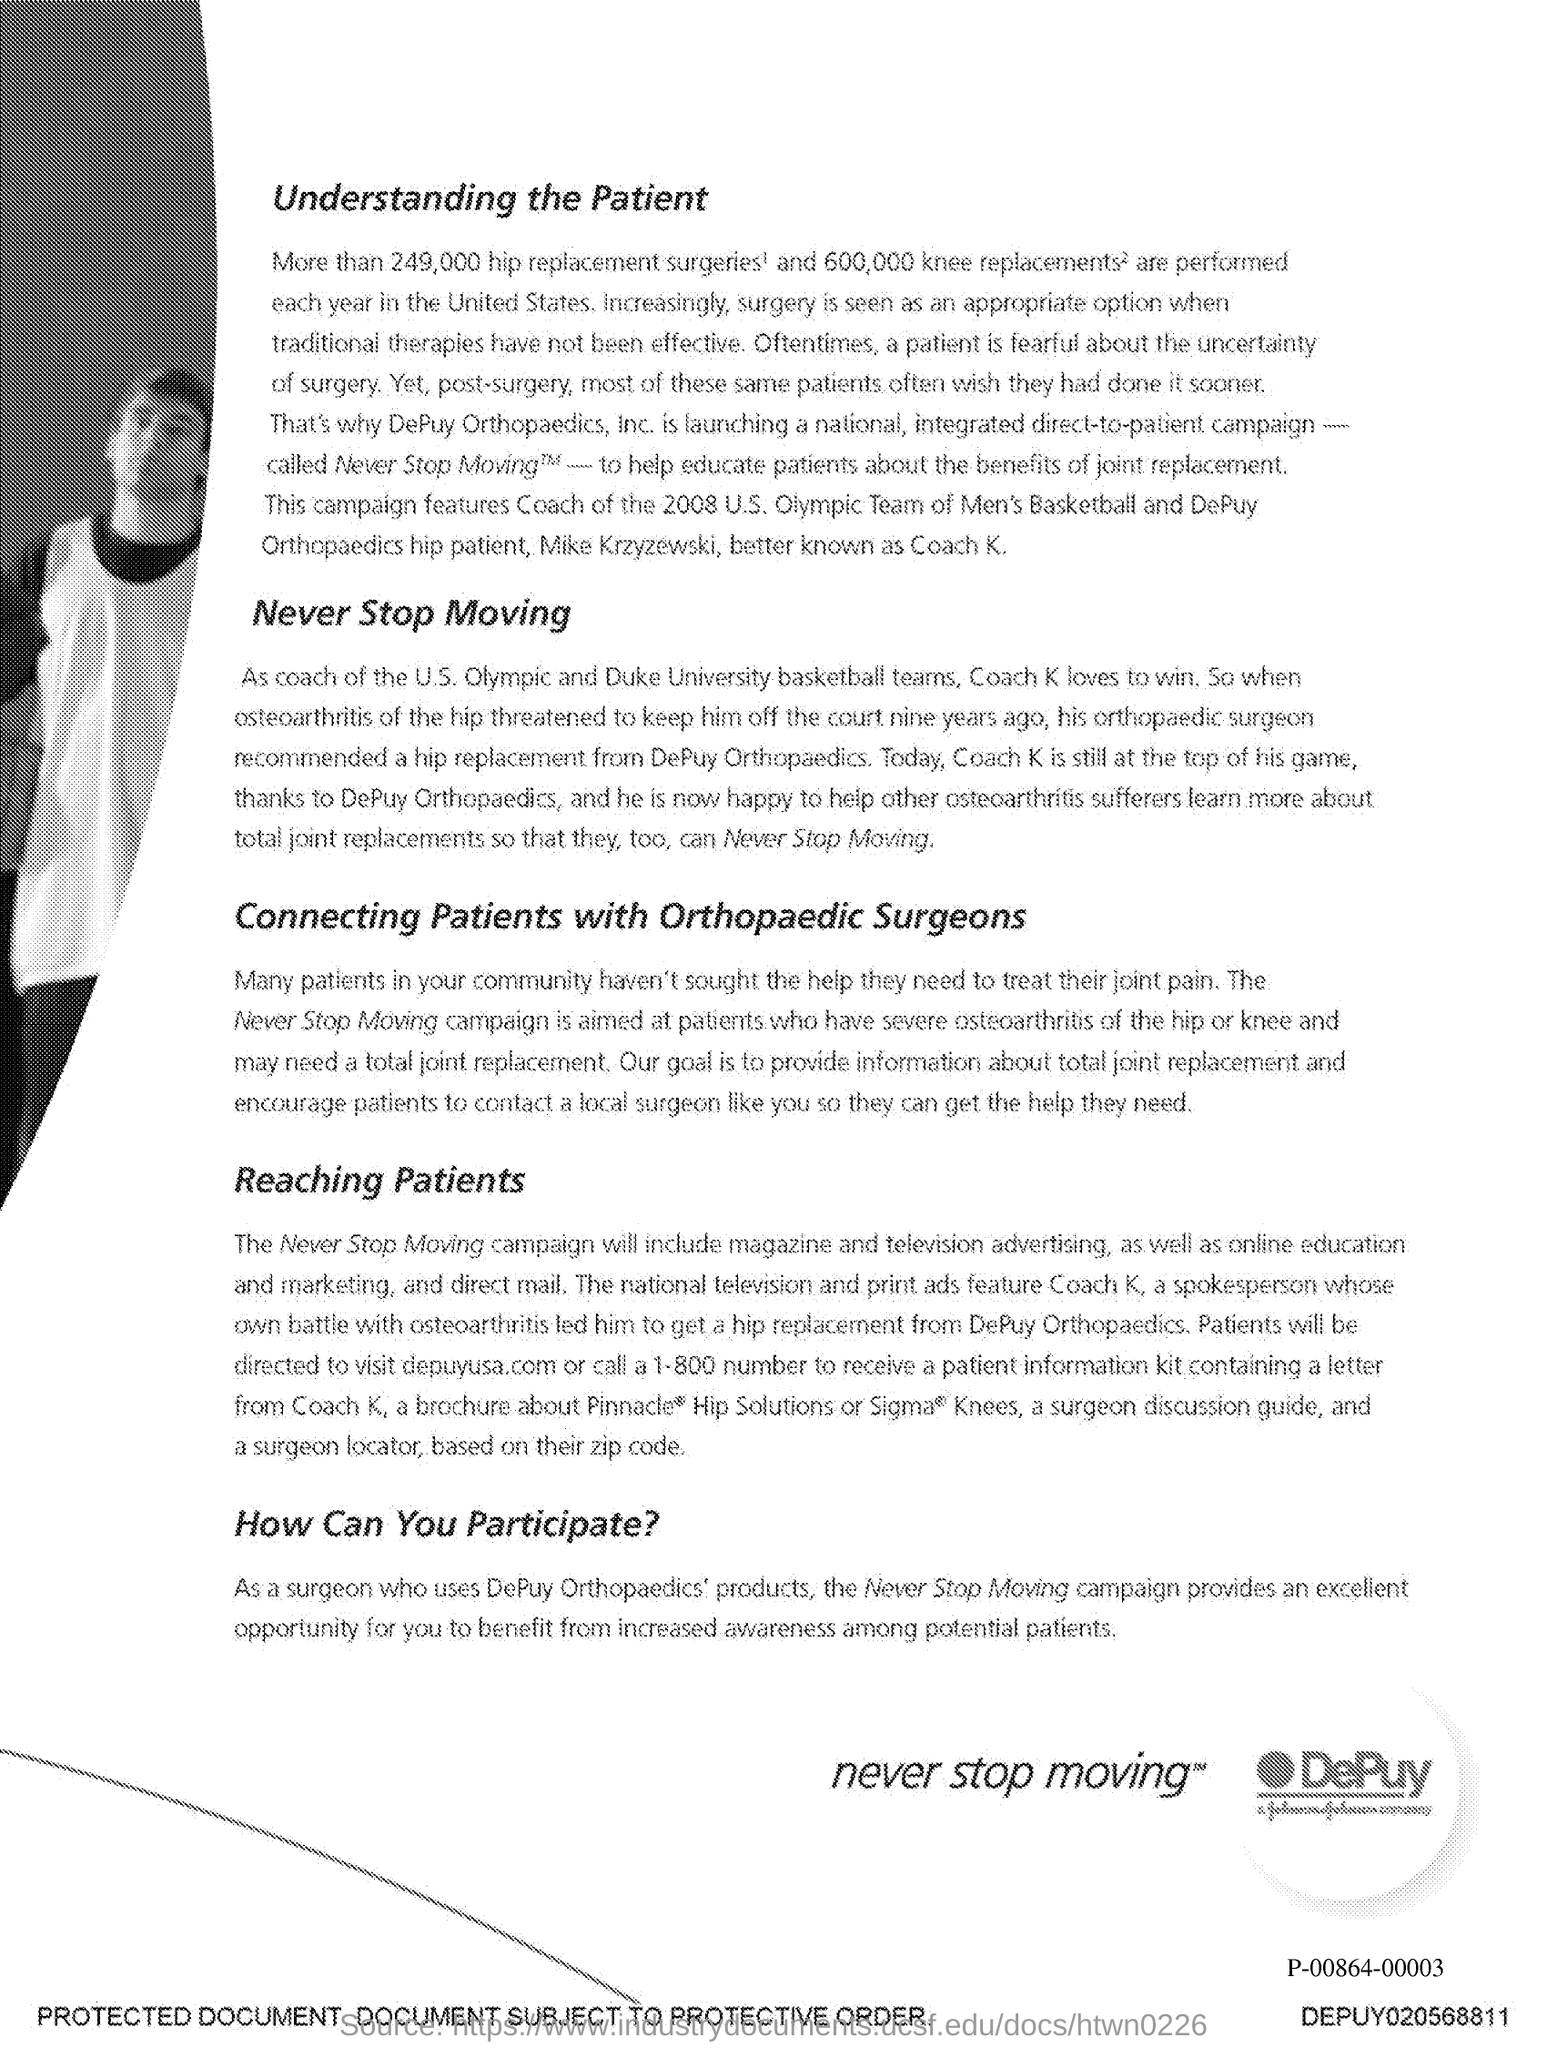What is the first title in the document?
Your response must be concise. Understanding the Patient. What is the second title in this document?
Ensure brevity in your answer.  Never Stop Moving. 